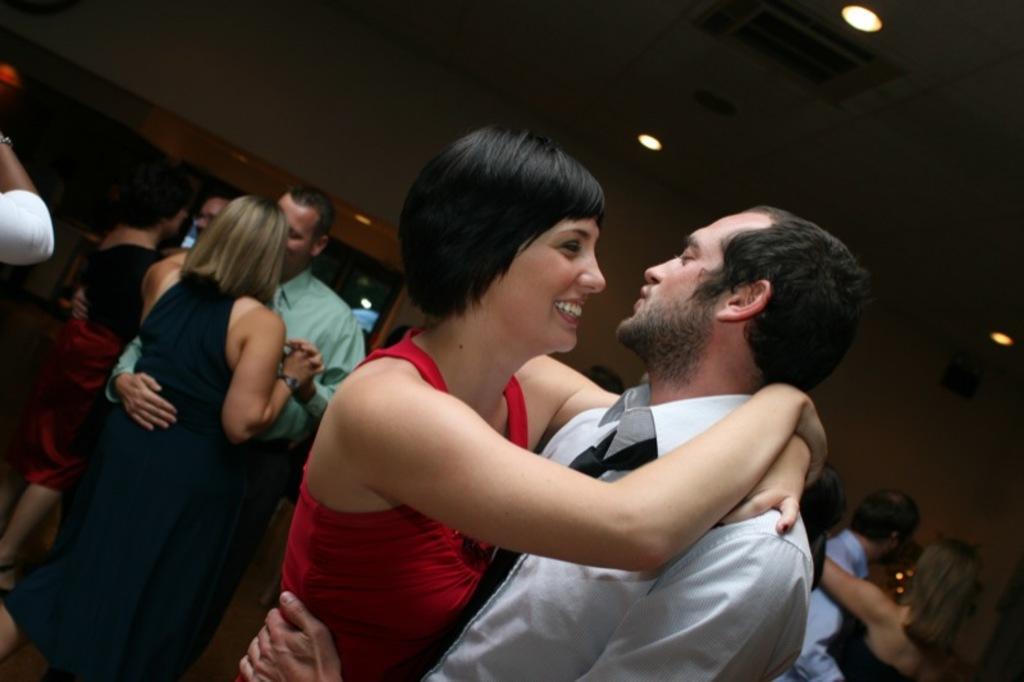How would you summarize this image in a sentence or two? In this picture there is a woman who is wearing red dress. He is standing near to the man who is wearing grey t-shirt. In the background we can see the group of persons were dancing on the floor. At the top we can see light. 